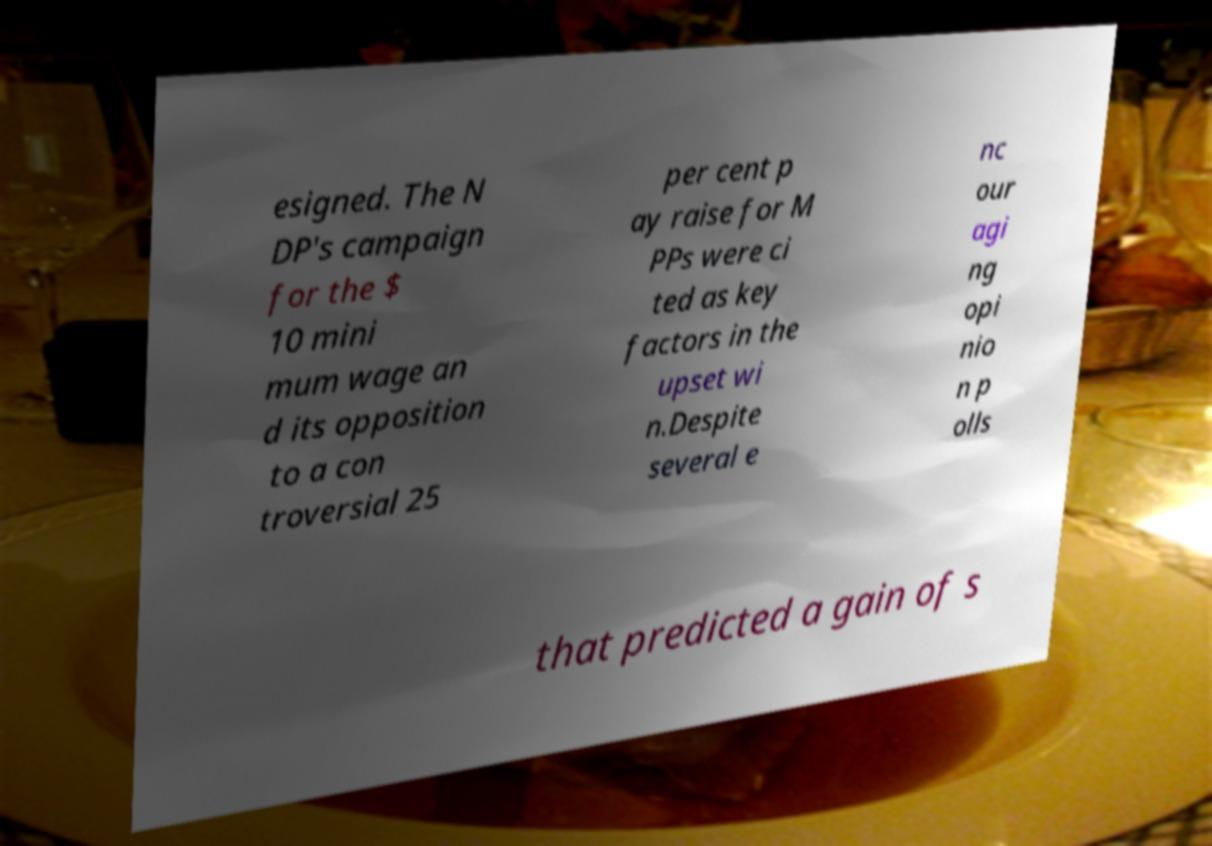Can you accurately transcribe the text from the provided image for me? esigned. The N DP's campaign for the $ 10 mini mum wage an d its opposition to a con troversial 25 per cent p ay raise for M PPs were ci ted as key factors in the upset wi n.Despite several e nc our agi ng opi nio n p olls that predicted a gain of s 